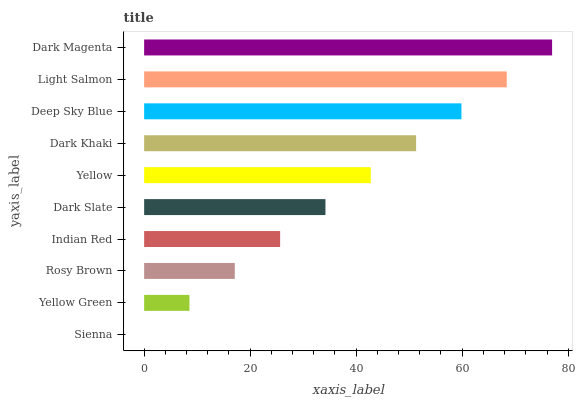Is Sienna the minimum?
Answer yes or no. Yes. Is Dark Magenta the maximum?
Answer yes or no. Yes. Is Yellow Green the minimum?
Answer yes or no. No. Is Yellow Green the maximum?
Answer yes or no. No. Is Yellow Green greater than Sienna?
Answer yes or no. Yes. Is Sienna less than Yellow Green?
Answer yes or no. Yes. Is Sienna greater than Yellow Green?
Answer yes or no. No. Is Yellow Green less than Sienna?
Answer yes or no. No. Is Yellow the high median?
Answer yes or no. Yes. Is Dark Slate the low median?
Answer yes or no. Yes. Is Indian Red the high median?
Answer yes or no. No. Is Yellow the low median?
Answer yes or no. No. 